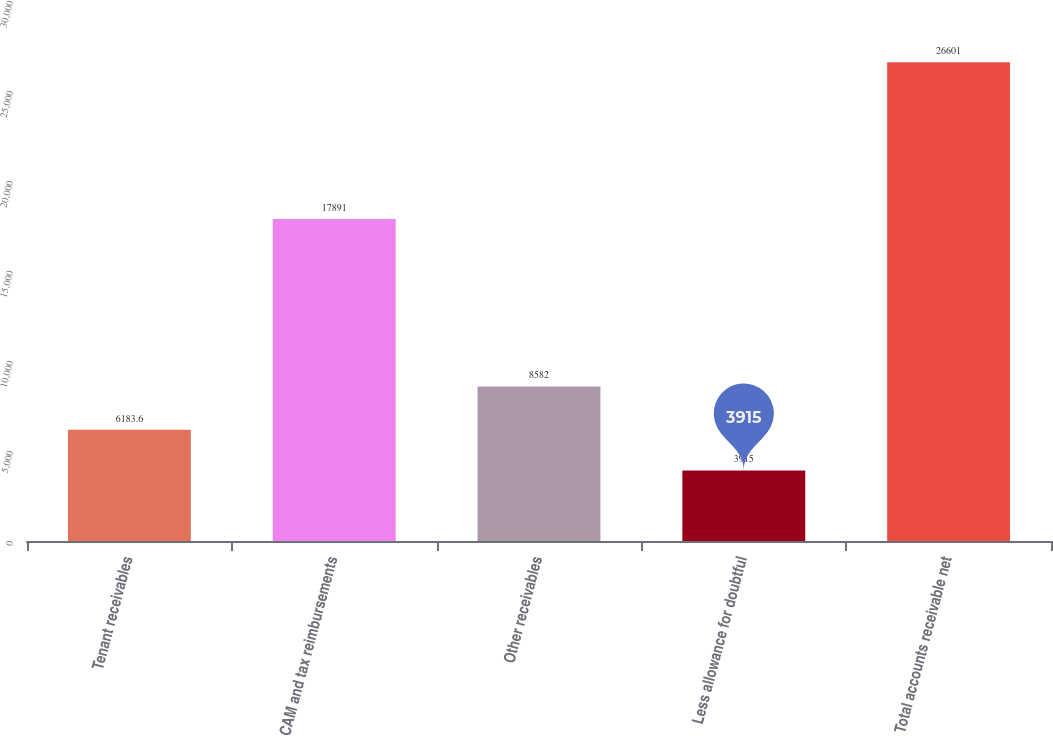<chart> <loc_0><loc_0><loc_500><loc_500><bar_chart><fcel>Tenant receivables<fcel>CAM and tax reimbursements<fcel>Other receivables<fcel>Less allowance for doubtful<fcel>Total accounts receivable net<nl><fcel>6183.6<fcel>17891<fcel>8582<fcel>3915<fcel>26601<nl></chart> 